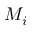Convert formula to latex. <formula><loc_0><loc_0><loc_500><loc_500>M _ { i }</formula> 